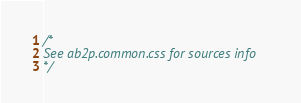Convert code to text. <code><loc_0><loc_0><loc_500><loc_500><_CSS_>/*
See ab2p.common.css for sources info
*/</code> 